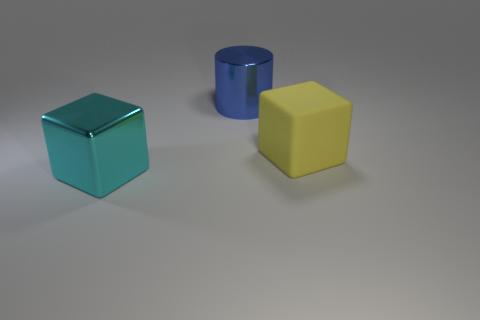What number of other things are there of the same size as the rubber cube?
Keep it short and to the point. 2. The large metal object that is behind the big metal thing in front of the big yellow object is what color?
Make the answer very short. Blue. What number of other objects are the same shape as the big blue metallic object?
Your response must be concise. 0. Is there another object that has the same material as the large blue thing?
Offer a terse response. Yes. There is a blue thing that is the same size as the cyan cube; what material is it?
Keep it short and to the point. Metal. There is a object behind the large cube behind the shiny thing that is in front of the big yellow object; what color is it?
Your answer should be very brief. Blue. There is a thing in front of the yellow matte block; is it the same shape as the big yellow rubber object that is in front of the blue cylinder?
Your response must be concise. Yes. What number of big things are there?
Keep it short and to the point. 3. There is another block that is the same size as the matte cube; what is its color?
Keep it short and to the point. Cyan. Do the large block that is on the right side of the blue object and the large block that is in front of the yellow cube have the same material?
Offer a very short reply. No. 